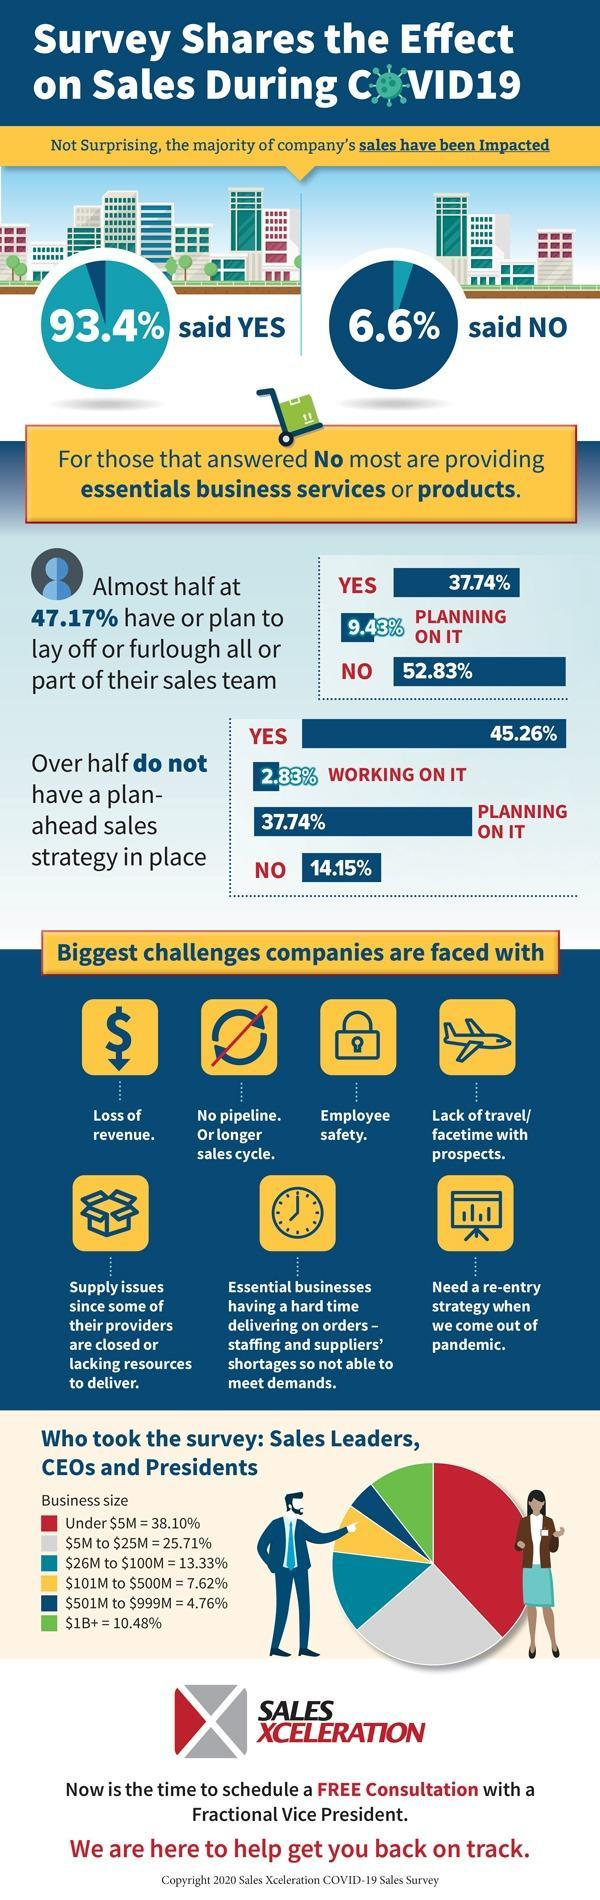Lack of travel picturized using which symbol-car, plane?
Answer the question with a short phrase. plane Employee safety picturized using which symbol-key, lock? lock Supply issues picturized using which symbol-bag, box? box 